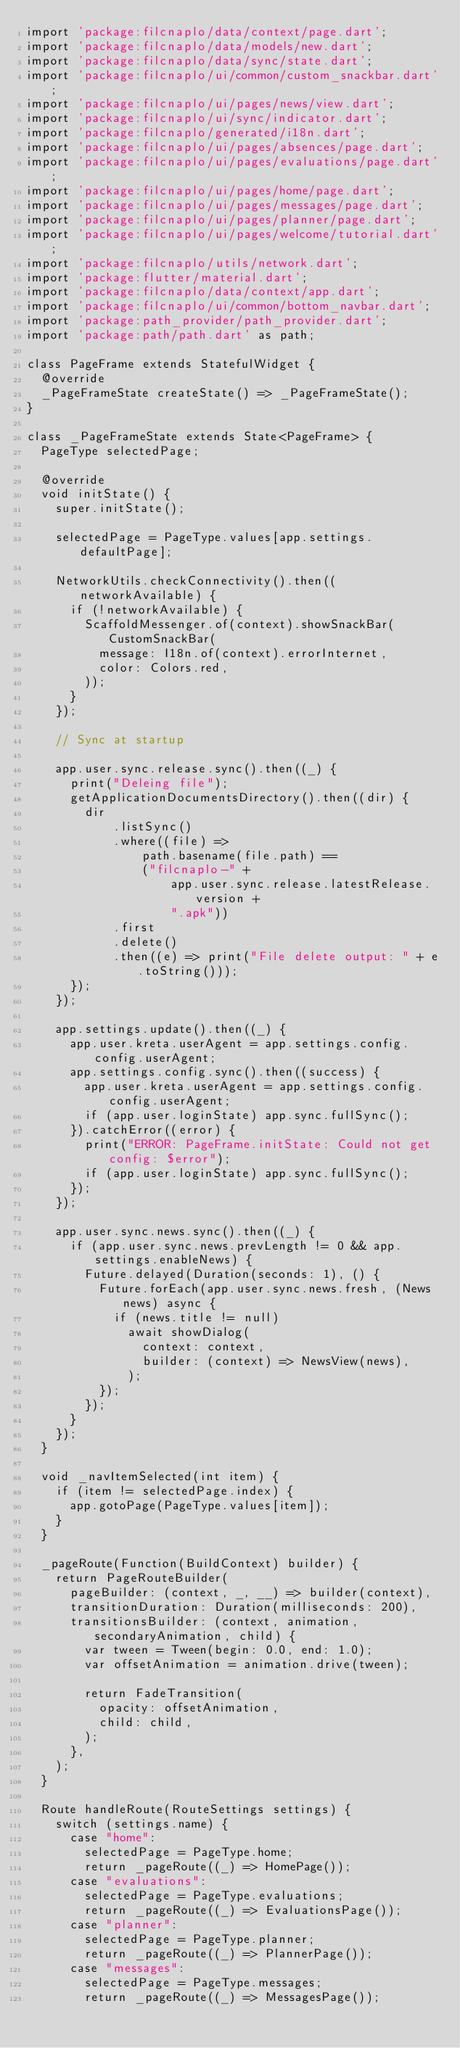Convert code to text. <code><loc_0><loc_0><loc_500><loc_500><_Dart_>import 'package:filcnaplo/data/context/page.dart';
import 'package:filcnaplo/data/models/new.dart';
import 'package:filcnaplo/data/sync/state.dart';
import 'package:filcnaplo/ui/common/custom_snackbar.dart';
import 'package:filcnaplo/ui/pages/news/view.dart';
import 'package:filcnaplo/ui/sync/indicator.dart';
import 'package:filcnaplo/generated/i18n.dart';
import 'package:filcnaplo/ui/pages/absences/page.dart';
import 'package:filcnaplo/ui/pages/evaluations/page.dart';
import 'package:filcnaplo/ui/pages/home/page.dart';
import 'package:filcnaplo/ui/pages/messages/page.dart';
import 'package:filcnaplo/ui/pages/planner/page.dart';
import 'package:filcnaplo/ui/pages/welcome/tutorial.dart';
import 'package:filcnaplo/utils/network.dart';
import 'package:flutter/material.dart';
import 'package:filcnaplo/data/context/app.dart';
import 'package:filcnaplo/ui/common/bottom_navbar.dart';
import 'package:path_provider/path_provider.dart';
import 'package:path/path.dart' as path;

class PageFrame extends StatefulWidget {
  @override
  _PageFrameState createState() => _PageFrameState();
}

class _PageFrameState extends State<PageFrame> {
  PageType selectedPage;

  @override
  void initState() {
    super.initState();

    selectedPage = PageType.values[app.settings.defaultPage];

    NetworkUtils.checkConnectivity().then((networkAvailable) {
      if (!networkAvailable) {
        ScaffoldMessenger.of(context).showSnackBar(CustomSnackBar(
          message: I18n.of(context).errorInternet,
          color: Colors.red,
        ));
      }
    });

    // Sync at startup

    app.user.sync.release.sync().then((_) {
      print("Deleing file");
      getApplicationDocumentsDirectory().then((dir) {
        dir
            .listSync()
            .where((file) =>
                path.basename(file.path) ==
                ("filcnaplo-" +
                    app.user.sync.release.latestRelease.version +
                    ".apk"))
            .first
            .delete()
            .then((e) => print("File delete output: " + e.toString()));
      });
    });

    app.settings.update().then((_) {
      app.user.kreta.userAgent = app.settings.config.config.userAgent;
      app.settings.config.sync().then((success) {
        app.user.kreta.userAgent = app.settings.config.config.userAgent;
        if (app.user.loginState) app.sync.fullSync();
      }).catchError((error) {
        print("ERROR: PageFrame.initState: Could not get config: $error");
        if (app.user.loginState) app.sync.fullSync();
      });
    });

    app.user.sync.news.sync().then((_) {
      if (app.user.sync.news.prevLength != 0 && app.settings.enableNews) {
        Future.delayed(Duration(seconds: 1), () {
          Future.forEach(app.user.sync.news.fresh, (News news) async {
            if (news.title != null)
              await showDialog(
                context: context,
                builder: (context) => NewsView(news),
              );
          });
        });
      }
    });
  }

  void _navItemSelected(int item) {
    if (item != selectedPage.index) {
      app.gotoPage(PageType.values[item]);
    }
  }

  _pageRoute(Function(BuildContext) builder) {
    return PageRouteBuilder(
      pageBuilder: (context, _, __) => builder(context),
      transitionDuration: Duration(milliseconds: 200),
      transitionsBuilder: (context, animation, secondaryAnimation, child) {
        var tween = Tween(begin: 0.0, end: 1.0);
        var offsetAnimation = animation.drive(tween);

        return FadeTransition(
          opacity: offsetAnimation,
          child: child,
        );
      },
    );
  }

  Route handleRoute(RouteSettings settings) {
    switch (settings.name) {
      case "home":
        selectedPage = PageType.home;
        return _pageRoute((_) => HomePage());
      case "evaluations":
        selectedPage = PageType.evaluations;
        return _pageRoute((_) => EvaluationsPage());
      case "planner":
        selectedPage = PageType.planner;
        return _pageRoute((_) => PlannerPage());
      case "messages":
        selectedPage = PageType.messages;
        return _pageRoute((_) => MessagesPage());</code> 